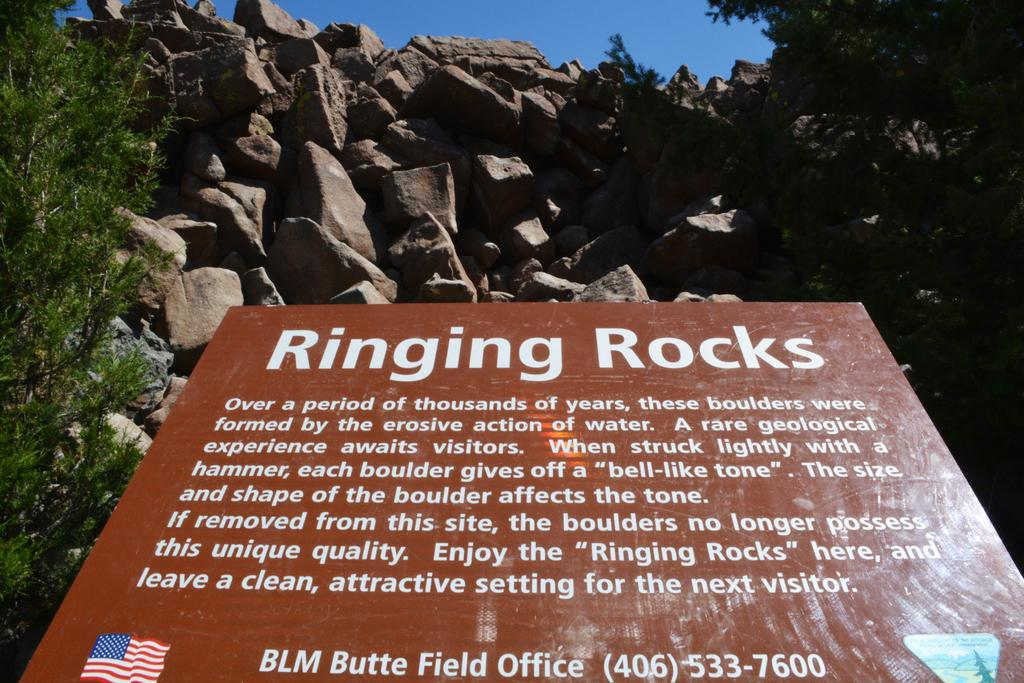What type of natural elements can be seen in the image? There are rocks in the image. Where is the tree located in the image? The tree is on the left side of the image. What is written or displayed on the board in the image? There is a board with text in the image. What is visible at the top of the image? The sky is visible at the top of the image. What type of veil is draped over the rocks in the image? There is no veil present in the image; it features rocks, a tree, a board with text, and the sky. What nerve is responsible for the movement of the tree in the image? Trees do not have nerves, and the movement of the tree is not depicted in the image. 